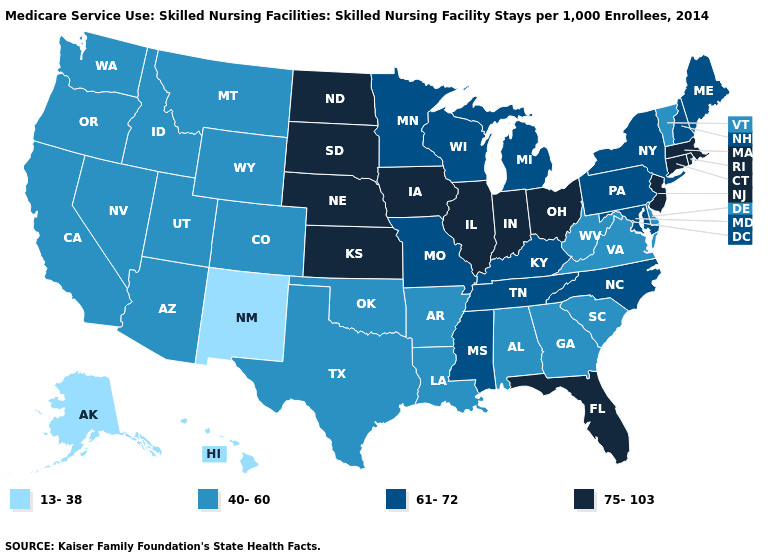Which states hav the highest value in the West?
Give a very brief answer. Arizona, California, Colorado, Idaho, Montana, Nevada, Oregon, Utah, Washington, Wyoming. Name the states that have a value in the range 61-72?
Quick response, please. Kentucky, Maine, Maryland, Michigan, Minnesota, Mississippi, Missouri, New Hampshire, New York, North Carolina, Pennsylvania, Tennessee, Wisconsin. Does North Dakota have the highest value in the USA?
Give a very brief answer. Yes. What is the highest value in the South ?
Give a very brief answer. 75-103. Does West Virginia have the lowest value in the South?
Give a very brief answer. Yes. Does Kansas have the same value as Idaho?
Concise answer only. No. Among the states that border Indiana , does Kentucky have the lowest value?
Be succinct. Yes. Does Oregon have the highest value in the West?
Give a very brief answer. Yes. Which states have the lowest value in the USA?
Give a very brief answer. Alaska, Hawaii, New Mexico. Name the states that have a value in the range 13-38?
Concise answer only. Alaska, Hawaii, New Mexico. Among the states that border South Carolina , which have the lowest value?
Concise answer only. Georgia. Does Montana have a higher value than Arkansas?
Short answer required. No. How many symbols are there in the legend?
Quick response, please. 4. What is the lowest value in the West?
Keep it brief. 13-38. What is the highest value in the USA?
Quick response, please. 75-103. 